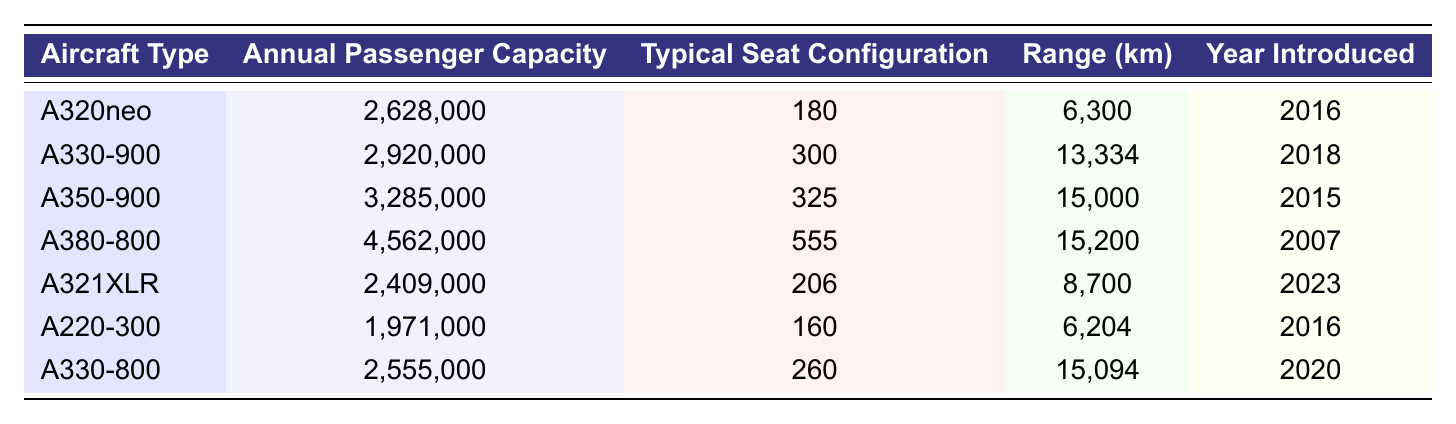What is the annual passenger capacity of the A330-900? The table lists the A330-900's annual passenger capacity as 2,920,000.
Answer: 2,920,000 Which aircraft type has the largest annual passenger capacity? By comparing the values in the table, the A380-800 has the largest annual passenger capacity at 4,562,000.
Answer: A380-800 What is the typical seat configuration for the A350-900? The table indicates that the typical seat configuration for the A350-900 is 325.
Answer: 325 How much greater is the annual passenger capacity of the A380-800 compared to the A220-300? The annual capacity of the A380-800 is 4,562,000 and that of the A220-300 is 1,971,000. The difference is 4,562,000 - 1,971,000 = 2,591,000.
Answer: 2,591,000 What is the range in kilometers of the A321XLR? The A321XLR has a range of 8,700 km according to the table.
Answer: 8,700 km Which aircraft was introduced first: the A350-900 or the A330-800? The A350-900 was introduced in 2015 and the A330-800 was introduced in 2020, so the A350-900 was introduced first.
Answer: A350-900 Is it true that the A220-300 has a higher annual passenger capacity than the A321XLR? The A220-300 has an annual passenger capacity of 1,971,000 and the A321XLR has 2,409,000; thus, the A220-300 has a lower capacity.
Answer: No What is the average annual passenger capacity of the A320neo, A330-900, and A350-900? The annual capacities are 2,628,000 (A320neo), 2,920,000 (A330-900), and 3,285,000 (A350-900). Summing these gives 2,628,000 + 2,920,000 + 3,285,000 = 8,833,000. Dividing by 3 yields an average of 2,944,333.33.
Answer: 2,944,333.33 Which aircraft types have a range greater than 10,000 km? From the table, the A330-900 (13,334 km), A350-900 (15,000 km), A380-800 (15,200 km), and A330-800 (15,094 km) have ranges greater than 10,000 km.
Answer: A330-900, A350-900, A380-800, A330-800 What is the only Airbus aircraft type introduced in 2023? The table shows that the A321XLR is the only Airbus aircraft introduced in the year 2023.
Answer: A321XLR 